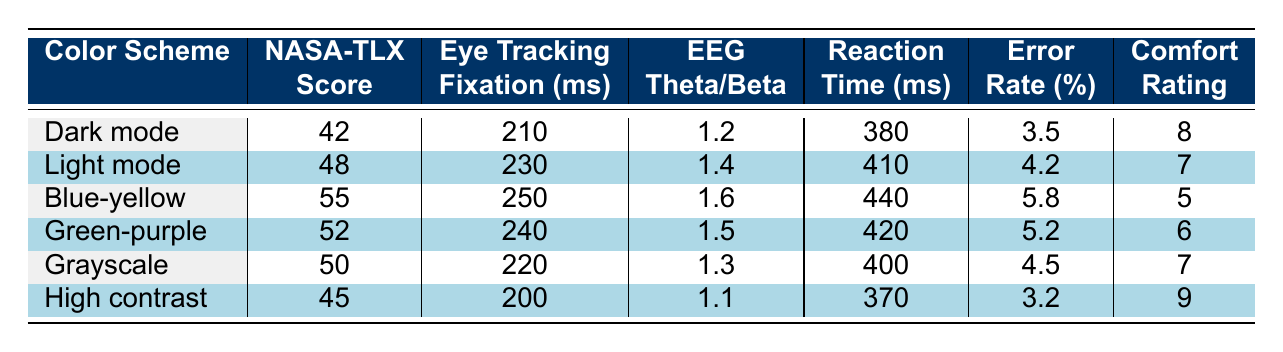What is the NASA-TLX score for Dark mode? Dark mode has a NASA-TLX score listed in the table as 42.
Answer: 42 Which color scheme has the highest eye tracking fixation duration? The Blue-yellow scheme has the highest eye tracking fixation duration at 250 ms, as shown in the table.
Answer: 250 ms What is the error rate for the Light mode? The Light mode has an error rate of 4.2%, which can be found in the corresponding row of the table.
Answer: 4.2% What is the average subjective comfort rating across all color schemes? To calculate the average, add all the comfort ratings (8 + 7 + 5 + 6 + 7 + 9 = 42) and divide by the number of schemes (6). So, 42/6 = 7.
Answer: 7 Is the reaction time for the High contrast scheme shorter than that of the Grayscale scheme? The reaction time for High contrast is 370 ms, while for Grayscale it is 400 ms. Since 370 ms is less than 400 ms, the statement is true.
Answer: Yes Which color scheme has the lowest EEG theta/beta ratio? The High contrast scheme has the lowest EEG theta/beta ratio at 1.1, as outlined in the table.
Answer: 1.1 If we compare the NASA-TLX scores of Dark mode and Grayscale, which one is better and by how much? Dark mode has a NASA-TLX score of 42 and Grayscale has 50. Since lower scores indicate better cognitive load, Grayscale is better by 8 points (50 - 42 = 8).
Answer: Grayscale is better by 8 points Which scheme has the highest error rate, and what is the value? The Blue-yellow scheme has the highest error rate of 5.8%, as indicated in the data.
Answer: 5.8% Calculate the difference in reaction time between the Light mode and the High contrast scheme. Light mode has a reaction time of 410 ms and High contrast has 370 ms. The difference is 410 - 370 = 40 ms.
Answer: 40 ms Did more color schemes have a subjective comfort rating of 7 or higher? There are four color schemes with a comfort rating of 7 or higher: Dark mode (8), Grayscale (7), and High contrast (9). Since there are three out of six, the answer is yes.
Answer: Yes 